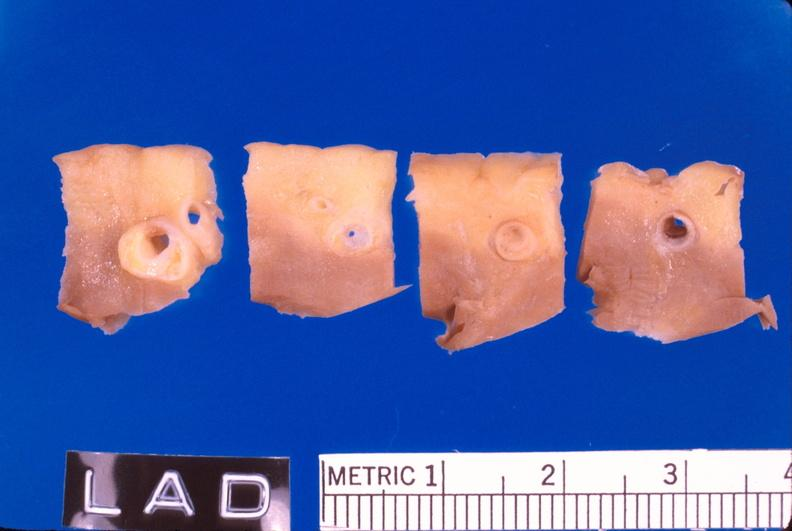what is present?
Answer the question using a single word or phrase. Cardiovascular 